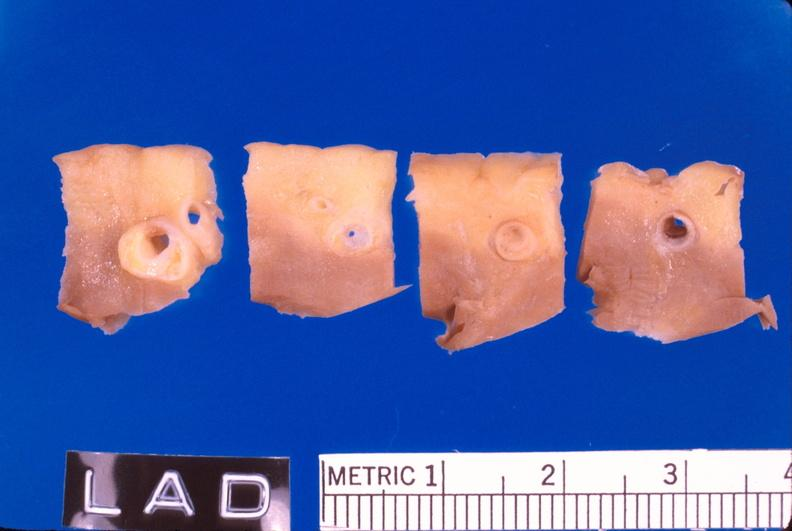what is present?
Answer the question using a single word or phrase. Cardiovascular 